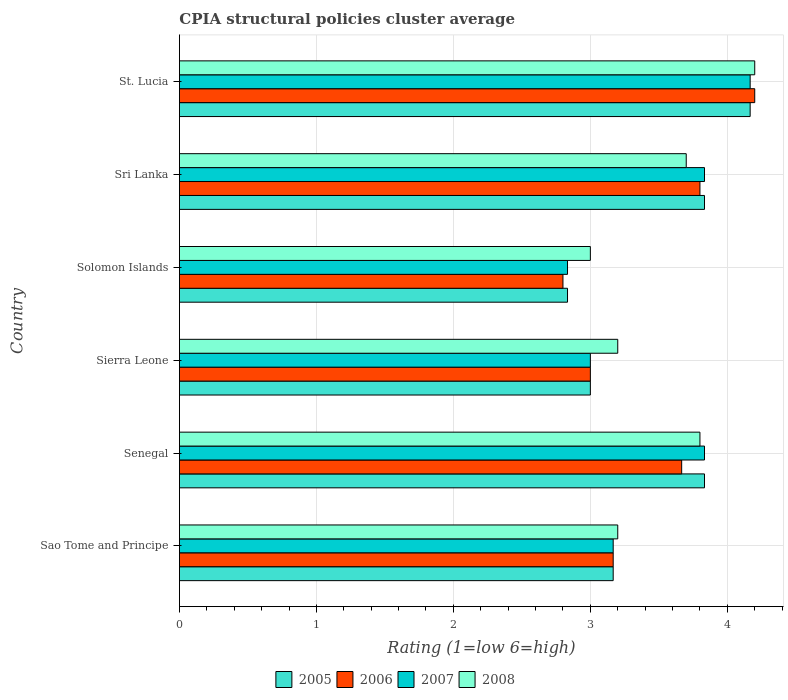How many different coloured bars are there?
Make the answer very short. 4. How many groups of bars are there?
Give a very brief answer. 6. Are the number of bars on each tick of the Y-axis equal?
Your answer should be compact. Yes. How many bars are there on the 2nd tick from the bottom?
Give a very brief answer. 4. What is the label of the 4th group of bars from the top?
Ensure brevity in your answer.  Sierra Leone. In how many cases, is the number of bars for a given country not equal to the number of legend labels?
Make the answer very short. 0. What is the CPIA rating in 2007 in St. Lucia?
Offer a terse response. 4.17. Across all countries, what is the maximum CPIA rating in 2005?
Give a very brief answer. 4.17. Across all countries, what is the minimum CPIA rating in 2007?
Offer a very short reply. 2.83. In which country was the CPIA rating in 2008 maximum?
Your response must be concise. St. Lucia. In which country was the CPIA rating in 2008 minimum?
Your response must be concise. Solomon Islands. What is the total CPIA rating in 2005 in the graph?
Give a very brief answer. 20.83. What is the difference between the CPIA rating in 2006 in Sierra Leone and that in St. Lucia?
Your response must be concise. -1.2. What is the difference between the CPIA rating in 2007 in Sierra Leone and the CPIA rating in 2008 in Sri Lanka?
Your response must be concise. -0.7. What is the average CPIA rating in 2005 per country?
Your response must be concise. 3.47. What is the difference between the CPIA rating in 2007 and CPIA rating in 2008 in St. Lucia?
Offer a very short reply. -0.03. In how many countries, is the CPIA rating in 2007 greater than 1.6 ?
Make the answer very short. 6. What is the ratio of the CPIA rating in 2007 in Sao Tome and Principe to that in Sri Lanka?
Keep it short and to the point. 0.83. What is the difference between the highest and the second highest CPIA rating in 2008?
Provide a succinct answer. 0.4. What is the difference between the highest and the lowest CPIA rating in 2006?
Provide a succinct answer. 1.4. What does the 2nd bar from the bottom in Sao Tome and Principe represents?
Make the answer very short. 2006. How many bars are there?
Your answer should be compact. 24. Are all the bars in the graph horizontal?
Keep it short and to the point. Yes. How are the legend labels stacked?
Offer a terse response. Horizontal. What is the title of the graph?
Give a very brief answer. CPIA structural policies cluster average. Does "1991" appear as one of the legend labels in the graph?
Your answer should be very brief. No. What is the label or title of the X-axis?
Make the answer very short. Rating (1=low 6=high). What is the label or title of the Y-axis?
Keep it short and to the point. Country. What is the Rating (1=low 6=high) in 2005 in Sao Tome and Principe?
Make the answer very short. 3.17. What is the Rating (1=low 6=high) in 2006 in Sao Tome and Principe?
Provide a succinct answer. 3.17. What is the Rating (1=low 6=high) of 2007 in Sao Tome and Principe?
Offer a very short reply. 3.17. What is the Rating (1=low 6=high) in 2008 in Sao Tome and Principe?
Provide a succinct answer. 3.2. What is the Rating (1=low 6=high) of 2005 in Senegal?
Provide a short and direct response. 3.83. What is the Rating (1=low 6=high) in 2006 in Senegal?
Give a very brief answer. 3.67. What is the Rating (1=low 6=high) of 2007 in Senegal?
Provide a short and direct response. 3.83. What is the Rating (1=low 6=high) in 2008 in Senegal?
Make the answer very short. 3.8. What is the Rating (1=low 6=high) of 2008 in Sierra Leone?
Offer a terse response. 3.2. What is the Rating (1=low 6=high) of 2005 in Solomon Islands?
Offer a terse response. 2.83. What is the Rating (1=low 6=high) of 2006 in Solomon Islands?
Keep it short and to the point. 2.8. What is the Rating (1=low 6=high) in 2007 in Solomon Islands?
Provide a short and direct response. 2.83. What is the Rating (1=low 6=high) in 2005 in Sri Lanka?
Ensure brevity in your answer.  3.83. What is the Rating (1=low 6=high) of 2006 in Sri Lanka?
Offer a very short reply. 3.8. What is the Rating (1=low 6=high) in 2007 in Sri Lanka?
Ensure brevity in your answer.  3.83. What is the Rating (1=low 6=high) in 2005 in St. Lucia?
Offer a terse response. 4.17. What is the Rating (1=low 6=high) in 2006 in St. Lucia?
Give a very brief answer. 4.2. What is the Rating (1=low 6=high) of 2007 in St. Lucia?
Provide a short and direct response. 4.17. What is the Rating (1=low 6=high) in 2008 in St. Lucia?
Your response must be concise. 4.2. Across all countries, what is the maximum Rating (1=low 6=high) of 2005?
Offer a very short reply. 4.17. Across all countries, what is the maximum Rating (1=low 6=high) in 2006?
Make the answer very short. 4.2. Across all countries, what is the maximum Rating (1=low 6=high) of 2007?
Keep it short and to the point. 4.17. Across all countries, what is the maximum Rating (1=low 6=high) in 2008?
Your answer should be compact. 4.2. Across all countries, what is the minimum Rating (1=low 6=high) of 2005?
Your response must be concise. 2.83. Across all countries, what is the minimum Rating (1=low 6=high) of 2006?
Make the answer very short. 2.8. Across all countries, what is the minimum Rating (1=low 6=high) of 2007?
Give a very brief answer. 2.83. Across all countries, what is the minimum Rating (1=low 6=high) in 2008?
Make the answer very short. 3. What is the total Rating (1=low 6=high) of 2005 in the graph?
Your response must be concise. 20.83. What is the total Rating (1=low 6=high) in 2006 in the graph?
Provide a short and direct response. 20.63. What is the total Rating (1=low 6=high) of 2007 in the graph?
Give a very brief answer. 20.83. What is the total Rating (1=low 6=high) in 2008 in the graph?
Provide a succinct answer. 21.1. What is the difference between the Rating (1=low 6=high) in 2006 in Sao Tome and Principe and that in Senegal?
Make the answer very short. -0.5. What is the difference between the Rating (1=low 6=high) of 2008 in Sao Tome and Principe and that in Senegal?
Provide a succinct answer. -0.6. What is the difference between the Rating (1=low 6=high) of 2005 in Sao Tome and Principe and that in Sierra Leone?
Your answer should be compact. 0.17. What is the difference between the Rating (1=low 6=high) in 2007 in Sao Tome and Principe and that in Sierra Leone?
Provide a short and direct response. 0.17. What is the difference between the Rating (1=low 6=high) of 2008 in Sao Tome and Principe and that in Sierra Leone?
Offer a terse response. 0. What is the difference between the Rating (1=low 6=high) of 2006 in Sao Tome and Principe and that in Solomon Islands?
Ensure brevity in your answer.  0.37. What is the difference between the Rating (1=low 6=high) of 2007 in Sao Tome and Principe and that in Solomon Islands?
Offer a very short reply. 0.33. What is the difference between the Rating (1=low 6=high) of 2005 in Sao Tome and Principe and that in Sri Lanka?
Make the answer very short. -0.67. What is the difference between the Rating (1=low 6=high) of 2006 in Sao Tome and Principe and that in Sri Lanka?
Make the answer very short. -0.63. What is the difference between the Rating (1=low 6=high) in 2006 in Sao Tome and Principe and that in St. Lucia?
Provide a succinct answer. -1.03. What is the difference between the Rating (1=low 6=high) of 2007 in Sao Tome and Principe and that in St. Lucia?
Offer a terse response. -1. What is the difference between the Rating (1=low 6=high) of 2008 in Sao Tome and Principe and that in St. Lucia?
Your answer should be very brief. -1. What is the difference between the Rating (1=low 6=high) in 2006 in Senegal and that in Sierra Leone?
Offer a very short reply. 0.67. What is the difference between the Rating (1=low 6=high) of 2008 in Senegal and that in Sierra Leone?
Offer a terse response. 0.6. What is the difference between the Rating (1=low 6=high) of 2006 in Senegal and that in Solomon Islands?
Your response must be concise. 0.87. What is the difference between the Rating (1=low 6=high) of 2007 in Senegal and that in Solomon Islands?
Keep it short and to the point. 1. What is the difference between the Rating (1=low 6=high) in 2005 in Senegal and that in Sri Lanka?
Give a very brief answer. 0. What is the difference between the Rating (1=low 6=high) of 2006 in Senegal and that in Sri Lanka?
Ensure brevity in your answer.  -0.13. What is the difference between the Rating (1=low 6=high) of 2006 in Senegal and that in St. Lucia?
Make the answer very short. -0.53. What is the difference between the Rating (1=low 6=high) in 2007 in Senegal and that in St. Lucia?
Make the answer very short. -0.33. What is the difference between the Rating (1=low 6=high) in 2008 in Senegal and that in St. Lucia?
Your answer should be compact. -0.4. What is the difference between the Rating (1=low 6=high) in 2005 in Sierra Leone and that in Solomon Islands?
Your response must be concise. 0.17. What is the difference between the Rating (1=low 6=high) in 2006 in Sierra Leone and that in Solomon Islands?
Provide a succinct answer. 0.2. What is the difference between the Rating (1=low 6=high) in 2007 in Sierra Leone and that in Solomon Islands?
Ensure brevity in your answer.  0.17. What is the difference between the Rating (1=low 6=high) of 2008 in Sierra Leone and that in Solomon Islands?
Your answer should be compact. 0.2. What is the difference between the Rating (1=low 6=high) of 2006 in Sierra Leone and that in Sri Lanka?
Give a very brief answer. -0.8. What is the difference between the Rating (1=low 6=high) in 2007 in Sierra Leone and that in Sri Lanka?
Offer a very short reply. -0.83. What is the difference between the Rating (1=low 6=high) in 2005 in Sierra Leone and that in St. Lucia?
Offer a terse response. -1.17. What is the difference between the Rating (1=low 6=high) of 2007 in Sierra Leone and that in St. Lucia?
Offer a terse response. -1.17. What is the difference between the Rating (1=low 6=high) in 2005 in Solomon Islands and that in Sri Lanka?
Provide a succinct answer. -1. What is the difference between the Rating (1=low 6=high) of 2008 in Solomon Islands and that in Sri Lanka?
Make the answer very short. -0.7. What is the difference between the Rating (1=low 6=high) in 2005 in Solomon Islands and that in St. Lucia?
Give a very brief answer. -1.33. What is the difference between the Rating (1=low 6=high) in 2006 in Solomon Islands and that in St. Lucia?
Offer a very short reply. -1.4. What is the difference between the Rating (1=low 6=high) in 2007 in Solomon Islands and that in St. Lucia?
Keep it short and to the point. -1.33. What is the difference between the Rating (1=low 6=high) in 2005 in Sri Lanka and that in St. Lucia?
Give a very brief answer. -0.33. What is the difference between the Rating (1=low 6=high) of 2006 in Sri Lanka and that in St. Lucia?
Ensure brevity in your answer.  -0.4. What is the difference between the Rating (1=low 6=high) in 2007 in Sri Lanka and that in St. Lucia?
Give a very brief answer. -0.33. What is the difference between the Rating (1=low 6=high) of 2005 in Sao Tome and Principe and the Rating (1=low 6=high) of 2006 in Senegal?
Ensure brevity in your answer.  -0.5. What is the difference between the Rating (1=low 6=high) of 2005 in Sao Tome and Principe and the Rating (1=low 6=high) of 2008 in Senegal?
Your answer should be very brief. -0.63. What is the difference between the Rating (1=low 6=high) in 2006 in Sao Tome and Principe and the Rating (1=low 6=high) in 2008 in Senegal?
Provide a succinct answer. -0.63. What is the difference between the Rating (1=low 6=high) in 2007 in Sao Tome and Principe and the Rating (1=low 6=high) in 2008 in Senegal?
Make the answer very short. -0.63. What is the difference between the Rating (1=low 6=high) in 2005 in Sao Tome and Principe and the Rating (1=low 6=high) in 2006 in Sierra Leone?
Offer a very short reply. 0.17. What is the difference between the Rating (1=low 6=high) of 2005 in Sao Tome and Principe and the Rating (1=low 6=high) of 2008 in Sierra Leone?
Your answer should be very brief. -0.03. What is the difference between the Rating (1=low 6=high) in 2006 in Sao Tome and Principe and the Rating (1=low 6=high) in 2008 in Sierra Leone?
Provide a short and direct response. -0.03. What is the difference between the Rating (1=low 6=high) of 2007 in Sao Tome and Principe and the Rating (1=low 6=high) of 2008 in Sierra Leone?
Your answer should be very brief. -0.03. What is the difference between the Rating (1=low 6=high) in 2005 in Sao Tome and Principe and the Rating (1=low 6=high) in 2006 in Solomon Islands?
Make the answer very short. 0.37. What is the difference between the Rating (1=low 6=high) in 2005 in Sao Tome and Principe and the Rating (1=low 6=high) in 2007 in Solomon Islands?
Give a very brief answer. 0.33. What is the difference between the Rating (1=low 6=high) of 2005 in Sao Tome and Principe and the Rating (1=low 6=high) of 2008 in Solomon Islands?
Ensure brevity in your answer.  0.17. What is the difference between the Rating (1=low 6=high) in 2006 in Sao Tome and Principe and the Rating (1=low 6=high) in 2007 in Solomon Islands?
Offer a very short reply. 0.33. What is the difference between the Rating (1=low 6=high) in 2006 in Sao Tome and Principe and the Rating (1=low 6=high) in 2008 in Solomon Islands?
Make the answer very short. 0.17. What is the difference between the Rating (1=low 6=high) of 2007 in Sao Tome and Principe and the Rating (1=low 6=high) of 2008 in Solomon Islands?
Give a very brief answer. 0.17. What is the difference between the Rating (1=low 6=high) of 2005 in Sao Tome and Principe and the Rating (1=low 6=high) of 2006 in Sri Lanka?
Ensure brevity in your answer.  -0.63. What is the difference between the Rating (1=low 6=high) in 2005 in Sao Tome and Principe and the Rating (1=low 6=high) in 2007 in Sri Lanka?
Your answer should be very brief. -0.67. What is the difference between the Rating (1=low 6=high) in 2005 in Sao Tome and Principe and the Rating (1=low 6=high) in 2008 in Sri Lanka?
Provide a short and direct response. -0.53. What is the difference between the Rating (1=low 6=high) in 2006 in Sao Tome and Principe and the Rating (1=low 6=high) in 2007 in Sri Lanka?
Give a very brief answer. -0.67. What is the difference between the Rating (1=low 6=high) in 2006 in Sao Tome and Principe and the Rating (1=low 6=high) in 2008 in Sri Lanka?
Provide a short and direct response. -0.53. What is the difference between the Rating (1=low 6=high) in 2007 in Sao Tome and Principe and the Rating (1=low 6=high) in 2008 in Sri Lanka?
Make the answer very short. -0.53. What is the difference between the Rating (1=low 6=high) of 2005 in Sao Tome and Principe and the Rating (1=low 6=high) of 2006 in St. Lucia?
Offer a terse response. -1.03. What is the difference between the Rating (1=low 6=high) in 2005 in Sao Tome and Principe and the Rating (1=low 6=high) in 2007 in St. Lucia?
Make the answer very short. -1. What is the difference between the Rating (1=low 6=high) in 2005 in Sao Tome and Principe and the Rating (1=low 6=high) in 2008 in St. Lucia?
Your answer should be compact. -1.03. What is the difference between the Rating (1=low 6=high) of 2006 in Sao Tome and Principe and the Rating (1=low 6=high) of 2007 in St. Lucia?
Keep it short and to the point. -1. What is the difference between the Rating (1=low 6=high) of 2006 in Sao Tome and Principe and the Rating (1=low 6=high) of 2008 in St. Lucia?
Your answer should be compact. -1.03. What is the difference between the Rating (1=low 6=high) of 2007 in Sao Tome and Principe and the Rating (1=low 6=high) of 2008 in St. Lucia?
Your answer should be very brief. -1.03. What is the difference between the Rating (1=low 6=high) in 2005 in Senegal and the Rating (1=low 6=high) in 2006 in Sierra Leone?
Offer a very short reply. 0.83. What is the difference between the Rating (1=low 6=high) in 2005 in Senegal and the Rating (1=low 6=high) in 2008 in Sierra Leone?
Make the answer very short. 0.63. What is the difference between the Rating (1=low 6=high) of 2006 in Senegal and the Rating (1=low 6=high) of 2008 in Sierra Leone?
Give a very brief answer. 0.47. What is the difference between the Rating (1=low 6=high) in 2007 in Senegal and the Rating (1=low 6=high) in 2008 in Sierra Leone?
Make the answer very short. 0.63. What is the difference between the Rating (1=low 6=high) in 2006 in Senegal and the Rating (1=low 6=high) in 2007 in Solomon Islands?
Offer a very short reply. 0.83. What is the difference between the Rating (1=low 6=high) of 2006 in Senegal and the Rating (1=low 6=high) of 2008 in Solomon Islands?
Your response must be concise. 0.67. What is the difference between the Rating (1=low 6=high) in 2005 in Senegal and the Rating (1=low 6=high) in 2006 in Sri Lanka?
Your answer should be compact. 0.03. What is the difference between the Rating (1=low 6=high) in 2005 in Senegal and the Rating (1=low 6=high) in 2007 in Sri Lanka?
Make the answer very short. 0. What is the difference between the Rating (1=low 6=high) of 2005 in Senegal and the Rating (1=low 6=high) of 2008 in Sri Lanka?
Your response must be concise. 0.13. What is the difference between the Rating (1=low 6=high) of 2006 in Senegal and the Rating (1=low 6=high) of 2007 in Sri Lanka?
Provide a succinct answer. -0.17. What is the difference between the Rating (1=low 6=high) of 2006 in Senegal and the Rating (1=low 6=high) of 2008 in Sri Lanka?
Make the answer very short. -0.03. What is the difference between the Rating (1=low 6=high) of 2007 in Senegal and the Rating (1=low 6=high) of 2008 in Sri Lanka?
Provide a succinct answer. 0.13. What is the difference between the Rating (1=low 6=high) in 2005 in Senegal and the Rating (1=low 6=high) in 2006 in St. Lucia?
Provide a succinct answer. -0.37. What is the difference between the Rating (1=low 6=high) in 2005 in Senegal and the Rating (1=low 6=high) in 2008 in St. Lucia?
Keep it short and to the point. -0.37. What is the difference between the Rating (1=low 6=high) in 2006 in Senegal and the Rating (1=low 6=high) in 2008 in St. Lucia?
Your answer should be very brief. -0.53. What is the difference between the Rating (1=low 6=high) in 2007 in Senegal and the Rating (1=low 6=high) in 2008 in St. Lucia?
Provide a succinct answer. -0.37. What is the difference between the Rating (1=low 6=high) in 2005 in Sierra Leone and the Rating (1=low 6=high) in 2006 in Solomon Islands?
Provide a short and direct response. 0.2. What is the difference between the Rating (1=low 6=high) of 2005 in Sierra Leone and the Rating (1=low 6=high) of 2007 in Solomon Islands?
Offer a very short reply. 0.17. What is the difference between the Rating (1=low 6=high) of 2005 in Sierra Leone and the Rating (1=low 6=high) of 2008 in Solomon Islands?
Offer a very short reply. 0. What is the difference between the Rating (1=low 6=high) in 2006 in Sierra Leone and the Rating (1=low 6=high) in 2008 in Solomon Islands?
Offer a terse response. 0. What is the difference between the Rating (1=low 6=high) of 2007 in Sierra Leone and the Rating (1=low 6=high) of 2008 in Solomon Islands?
Your response must be concise. 0. What is the difference between the Rating (1=low 6=high) in 2005 in Sierra Leone and the Rating (1=low 6=high) in 2006 in Sri Lanka?
Provide a succinct answer. -0.8. What is the difference between the Rating (1=low 6=high) in 2006 in Sierra Leone and the Rating (1=low 6=high) in 2007 in Sri Lanka?
Your response must be concise. -0.83. What is the difference between the Rating (1=low 6=high) in 2007 in Sierra Leone and the Rating (1=low 6=high) in 2008 in Sri Lanka?
Ensure brevity in your answer.  -0.7. What is the difference between the Rating (1=low 6=high) of 2005 in Sierra Leone and the Rating (1=low 6=high) of 2007 in St. Lucia?
Give a very brief answer. -1.17. What is the difference between the Rating (1=low 6=high) in 2006 in Sierra Leone and the Rating (1=low 6=high) in 2007 in St. Lucia?
Ensure brevity in your answer.  -1.17. What is the difference between the Rating (1=low 6=high) of 2005 in Solomon Islands and the Rating (1=low 6=high) of 2006 in Sri Lanka?
Your response must be concise. -0.97. What is the difference between the Rating (1=low 6=high) of 2005 in Solomon Islands and the Rating (1=low 6=high) of 2007 in Sri Lanka?
Provide a short and direct response. -1. What is the difference between the Rating (1=low 6=high) of 2005 in Solomon Islands and the Rating (1=low 6=high) of 2008 in Sri Lanka?
Ensure brevity in your answer.  -0.87. What is the difference between the Rating (1=low 6=high) in 2006 in Solomon Islands and the Rating (1=low 6=high) in 2007 in Sri Lanka?
Give a very brief answer. -1.03. What is the difference between the Rating (1=low 6=high) of 2006 in Solomon Islands and the Rating (1=low 6=high) of 2008 in Sri Lanka?
Keep it short and to the point. -0.9. What is the difference between the Rating (1=low 6=high) of 2007 in Solomon Islands and the Rating (1=low 6=high) of 2008 in Sri Lanka?
Your answer should be very brief. -0.87. What is the difference between the Rating (1=low 6=high) in 2005 in Solomon Islands and the Rating (1=low 6=high) in 2006 in St. Lucia?
Provide a short and direct response. -1.37. What is the difference between the Rating (1=low 6=high) in 2005 in Solomon Islands and the Rating (1=low 6=high) in 2007 in St. Lucia?
Your response must be concise. -1.33. What is the difference between the Rating (1=low 6=high) of 2005 in Solomon Islands and the Rating (1=low 6=high) of 2008 in St. Lucia?
Offer a terse response. -1.37. What is the difference between the Rating (1=low 6=high) in 2006 in Solomon Islands and the Rating (1=low 6=high) in 2007 in St. Lucia?
Ensure brevity in your answer.  -1.37. What is the difference between the Rating (1=low 6=high) in 2006 in Solomon Islands and the Rating (1=low 6=high) in 2008 in St. Lucia?
Your answer should be compact. -1.4. What is the difference between the Rating (1=low 6=high) of 2007 in Solomon Islands and the Rating (1=low 6=high) of 2008 in St. Lucia?
Give a very brief answer. -1.37. What is the difference between the Rating (1=low 6=high) in 2005 in Sri Lanka and the Rating (1=low 6=high) in 2006 in St. Lucia?
Provide a short and direct response. -0.37. What is the difference between the Rating (1=low 6=high) in 2005 in Sri Lanka and the Rating (1=low 6=high) in 2007 in St. Lucia?
Your answer should be very brief. -0.33. What is the difference between the Rating (1=low 6=high) in 2005 in Sri Lanka and the Rating (1=low 6=high) in 2008 in St. Lucia?
Offer a very short reply. -0.37. What is the difference between the Rating (1=low 6=high) of 2006 in Sri Lanka and the Rating (1=low 6=high) of 2007 in St. Lucia?
Give a very brief answer. -0.37. What is the difference between the Rating (1=low 6=high) of 2007 in Sri Lanka and the Rating (1=low 6=high) of 2008 in St. Lucia?
Ensure brevity in your answer.  -0.37. What is the average Rating (1=low 6=high) in 2005 per country?
Keep it short and to the point. 3.47. What is the average Rating (1=low 6=high) in 2006 per country?
Offer a terse response. 3.44. What is the average Rating (1=low 6=high) of 2007 per country?
Keep it short and to the point. 3.47. What is the average Rating (1=low 6=high) of 2008 per country?
Offer a terse response. 3.52. What is the difference between the Rating (1=low 6=high) of 2005 and Rating (1=low 6=high) of 2006 in Sao Tome and Principe?
Offer a terse response. 0. What is the difference between the Rating (1=low 6=high) in 2005 and Rating (1=low 6=high) in 2007 in Sao Tome and Principe?
Your response must be concise. 0. What is the difference between the Rating (1=low 6=high) in 2005 and Rating (1=low 6=high) in 2008 in Sao Tome and Principe?
Give a very brief answer. -0.03. What is the difference between the Rating (1=low 6=high) of 2006 and Rating (1=low 6=high) of 2007 in Sao Tome and Principe?
Keep it short and to the point. 0. What is the difference between the Rating (1=low 6=high) of 2006 and Rating (1=low 6=high) of 2008 in Sao Tome and Principe?
Provide a succinct answer. -0.03. What is the difference between the Rating (1=low 6=high) in 2007 and Rating (1=low 6=high) in 2008 in Sao Tome and Principe?
Make the answer very short. -0.03. What is the difference between the Rating (1=low 6=high) of 2005 and Rating (1=low 6=high) of 2006 in Senegal?
Keep it short and to the point. 0.17. What is the difference between the Rating (1=low 6=high) in 2006 and Rating (1=low 6=high) in 2008 in Senegal?
Give a very brief answer. -0.13. What is the difference between the Rating (1=low 6=high) of 2005 and Rating (1=low 6=high) of 2006 in Sierra Leone?
Provide a short and direct response. 0. What is the difference between the Rating (1=low 6=high) in 2005 and Rating (1=low 6=high) in 2007 in Sierra Leone?
Offer a very short reply. 0. What is the difference between the Rating (1=low 6=high) of 2005 and Rating (1=low 6=high) of 2008 in Sierra Leone?
Keep it short and to the point. -0.2. What is the difference between the Rating (1=low 6=high) in 2006 and Rating (1=low 6=high) in 2007 in Sierra Leone?
Make the answer very short. 0. What is the difference between the Rating (1=low 6=high) in 2006 and Rating (1=low 6=high) in 2008 in Sierra Leone?
Your answer should be compact. -0.2. What is the difference between the Rating (1=low 6=high) of 2005 and Rating (1=low 6=high) of 2006 in Solomon Islands?
Ensure brevity in your answer.  0.03. What is the difference between the Rating (1=low 6=high) in 2005 and Rating (1=low 6=high) in 2008 in Solomon Islands?
Your response must be concise. -0.17. What is the difference between the Rating (1=low 6=high) of 2006 and Rating (1=low 6=high) of 2007 in Solomon Islands?
Keep it short and to the point. -0.03. What is the difference between the Rating (1=low 6=high) of 2007 and Rating (1=low 6=high) of 2008 in Solomon Islands?
Your answer should be compact. -0.17. What is the difference between the Rating (1=low 6=high) of 2005 and Rating (1=low 6=high) of 2006 in Sri Lanka?
Offer a very short reply. 0.03. What is the difference between the Rating (1=low 6=high) of 2005 and Rating (1=low 6=high) of 2007 in Sri Lanka?
Give a very brief answer. 0. What is the difference between the Rating (1=low 6=high) in 2005 and Rating (1=low 6=high) in 2008 in Sri Lanka?
Provide a short and direct response. 0.13. What is the difference between the Rating (1=low 6=high) of 2006 and Rating (1=low 6=high) of 2007 in Sri Lanka?
Offer a terse response. -0.03. What is the difference between the Rating (1=low 6=high) in 2006 and Rating (1=low 6=high) in 2008 in Sri Lanka?
Your answer should be very brief. 0.1. What is the difference between the Rating (1=low 6=high) of 2007 and Rating (1=low 6=high) of 2008 in Sri Lanka?
Offer a very short reply. 0.13. What is the difference between the Rating (1=low 6=high) of 2005 and Rating (1=low 6=high) of 2006 in St. Lucia?
Provide a short and direct response. -0.03. What is the difference between the Rating (1=low 6=high) in 2005 and Rating (1=low 6=high) in 2007 in St. Lucia?
Your answer should be very brief. 0. What is the difference between the Rating (1=low 6=high) in 2005 and Rating (1=low 6=high) in 2008 in St. Lucia?
Offer a very short reply. -0.03. What is the difference between the Rating (1=low 6=high) of 2006 and Rating (1=low 6=high) of 2007 in St. Lucia?
Make the answer very short. 0.03. What is the difference between the Rating (1=low 6=high) in 2007 and Rating (1=low 6=high) in 2008 in St. Lucia?
Keep it short and to the point. -0.03. What is the ratio of the Rating (1=low 6=high) in 2005 in Sao Tome and Principe to that in Senegal?
Make the answer very short. 0.83. What is the ratio of the Rating (1=low 6=high) of 2006 in Sao Tome and Principe to that in Senegal?
Offer a very short reply. 0.86. What is the ratio of the Rating (1=low 6=high) of 2007 in Sao Tome and Principe to that in Senegal?
Ensure brevity in your answer.  0.83. What is the ratio of the Rating (1=low 6=high) in 2008 in Sao Tome and Principe to that in Senegal?
Ensure brevity in your answer.  0.84. What is the ratio of the Rating (1=low 6=high) of 2005 in Sao Tome and Principe to that in Sierra Leone?
Ensure brevity in your answer.  1.06. What is the ratio of the Rating (1=low 6=high) in 2006 in Sao Tome and Principe to that in Sierra Leone?
Keep it short and to the point. 1.06. What is the ratio of the Rating (1=low 6=high) in 2007 in Sao Tome and Principe to that in Sierra Leone?
Provide a short and direct response. 1.06. What is the ratio of the Rating (1=low 6=high) in 2008 in Sao Tome and Principe to that in Sierra Leone?
Offer a very short reply. 1. What is the ratio of the Rating (1=low 6=high) of 2005 in Sao Tome and Principe to that in Solomon Islands?
Make the answer very short. 1.12. What is the ratio of the Rating (1=low 6=high) in 2006 in Sao Tome and Principe to that in Solomon Islands?
Provide a short and direct response. 1.13. What is the ratio of the Rating (1=low 6=high) in 2007 in Sao Tome and Principe to that in Solomon Islands?
Give a very brief answer. 1.12. What is the ratio of the Rating (1=low 6=high) in 2008 in Sao Tome and Principe to that in Solomon Islands?
Make the answer very short. 1.07. What is the ratio of the Rating (1=low 6=high) in 2005 in Sao Tome and Principe to that in Sri Lanka?
Keep it short and to the point. 0.83. What is the ratio of the Rating (1=low 6=high) in 2006 in Sao Tome and Principe to that in Sri Lanka?
Give a very brief answer. 0.83. What is the ratio of the Rating (1=low 6=high) in 2007 in Sao Tome and Principe to that in Sri Lanka?
Your answer should be compact. 0.83. What is the ratio of the Rating (1=low 6=high) in 2008 in Sao Tome and Principe to that in Sri Lanka?
Keep it short and to the point. 0.86. What is the ratio of the Rating (1=low 6=high) in 2005 in Sao Tome and Principe to that in St. Lucia?
Ensure brevity in your answer.  0.76. What is the ratio of the Rating (1=low 6=high) of 2006 in Sao Tome and Principe to that in St. Lucia?
Ensure brevity in your answer.  0.75. What is the ratio of the Rating (1=low 6=high) in 2007 in Sao Tome and Principe to that in St. Lucia?
Make the answer very short. 0.76. What is the ratio of the Rating (1=low 6=high) in 2008 in Sao Tome and Principe to that in St. Lucia?
Offer a very short reply. 0.76. What is the ratio of the Rating (1=low 6=high) of 2005 in Senegal to that in Sierra Leone?
Your answer should be compact. 1.28. What is the ratio of the Rating (1=low 6=high) in 2006 in Senegal to that in Sierra Leone?
Offer a terse response. 1.22. What is the ratio of the Rating (1=low 6=high) in 2007 in Senegal to that in Sierra Leone?
Your answer should be very brief. 1.28. What is the ratio of the Rating (1=low 6=high) of 2008 in Senegal to that in Sierra Leone?
Provide a succinct answer. 1.19. What is the ratio of the Rating (1=low 6=high) of 2005 in Senegal to that in Solomon Islands?
Give a very brief answer. 1.35. What is the ratio of the Rating (1=low 6=high) in 2006 in Senegal to that in Solomon Islands?
Give a very brief answer. 1.31. What is the ratio of the Rating (1=low 6=high) in 2007 in Senegal to that in Solomon Islands?
Ensure brevity in your answer.  1.35. What is the ratio of the Rating (1=low 6=high) in 2008 in Senegal to that in Solomon Islands?
Your answer should be compact. 1.27. What is the ratio of the Rating (1=low 6=high) of 2005 in Senegal to that in Sri Lanka?
Give a very brief answer. 1. What is the ratio of the Rating (1=low 6=high) in 2006 in Senegal to that in Sri Lanka?
Offer a terse response. 0.96. What is the ratio of the Rating (1=low 6=high) of 2008 in Senegal to that in Sri Lanka?
Your answer should be compact. 1.03. What is the ratio of the Rating (1=low 6=high) in 2006 in Senegal to that in St. Lucia?
Give a very brief answer. 0.87. What is the ratio of the Rating (1=low 6=high) of 2007 in Senegal to that in St. Lucia?
Provide a short and direct response. 0.92. What is the ratio of the Rating (1=low 6=high) in 2008 in Senegal to that in St. Lucia?
Give a very brief answer. 0.9. What is the ratio of the Rating (1=low 6=high) in 2005 in Sierra Leone to that in Solomon Islands?
Provide a short and direct response. 1.06. What is the ratio of the Rating (1=low 6=high) in 2006 in Sierra Leone to that in Solomon Islands?
Give a very brief answer. 1.07. What is the ratio of the Rating (1=low 6=high) of 2007 in Sierra Leone to that in Solomon Islands?
Offer a terse response. 1.06. What is the ratio of the Rating (1=low 6=high) of 2008 in Sierra Leone to that in Solomon Islands?
Make the answer very short. 1.07. What is the ratio of the Rating (1=low 6=high) of 2005 in Sierra Leone to that in Sri Lanka?
Provide a short and direct response. 0.78. What is the ratio of the Rating (1=low 6=high) in 2006 in Sierra Leone to that in Sri Lanka?
Your answer should be compact. 0.79. What is the ratio of the Rating (1=low 6=high) of 2007 in Sierra Leone to that in Sri Lanka?
Ensure brevity in your answer.  0.78. What is the ratio of the Rating (1=low 6=high) in 2008 in Sierra Leone to that in Sri Lanka?
Provide a short and direct response. 0.86. What is the ratio of the Rating (1=low 6=high) in 2005 in Sierra Leone to that in St. Lucia?
Your answer should be very brief. 0.72. What is the ratio of the Rating (1=low 6=high) of 2007 in Sierra Leone to that in St. Lucia?
Your response must be concise. 0.72. What is the ratio of the Rating (1=low 6=high) in 2008 in Sierra Leone to that in St. Lucia?
Your answer should be compact. 0.76. What is the ratio of the Rating (1=low 6=high) in 2005 in Solomon Islands to that in Sri Lanka?
Make the answer very short. 0.74. What is the ratio of the Rating (1=low 6=high) in 2006 in Solomon Islands to that in Sri Lanka?
Offer a terse response. 0.74. What is the ratio of the Rating (1=low 6=high) of 2007 in Solomon Islands to that in Sri Lanka?
Provide a succinct answer. 0.74. What is the ratio of the Rating (1=low 6=high) in 2008 in Solomon Islands to that in Sri Lanka?
Provide a short and direct response. 0.81. What is the ratio of the Rating (1=low 6=high) in 2005 in Solomon Islands to that in St. Lucia?
Keep it short and to the point. 0.68. What is the ratio of the Rating (1=low 6=high) in 2006 in Solomon Islands to that in St. Lucia?
Provide a succinct answer. 0.67. What is the ratio of the Rating (1=low 6=high) of 2007 in Solomon Islands to that in St. Lucia?
Offer a very short reply. 0.68. What is the ratio of the Rating (1=low 6=high) in 2006 in Sri Lanka to that in St. Lucia?
Give a very brief answer. 0.9. What is the ratio of the Rating (1=low 6=high) of 2008 in Sri Lanka to that in St. Lucia?
Your answer should be very brief. 0.88. What is the difference between the highest and the second highest Rating (1=low 6=high) in 2005?
Offer a terse response. 0.33. What is the difference between the highest and the second highest Rating (1=low 6=high) of 2007?
Offer a terse response. 0.33. What is the difference between the highest and the lowest Rating (1=low 6=high) in 2005?
Offer a very short reply. 1.33. What is the difference between the highest and the lowest Rating (1=low 6=high) in 2006?
Provide a succinct answer. 1.4. What is the difference between the highest and the lowest Rating (1=low 6=high) in 2007?
Offer a very short reply. 1.33. What is the difference between the highest and the lowest Rating (1=low 6=high) of 2008?
Your answer should be compact. 1.2. 